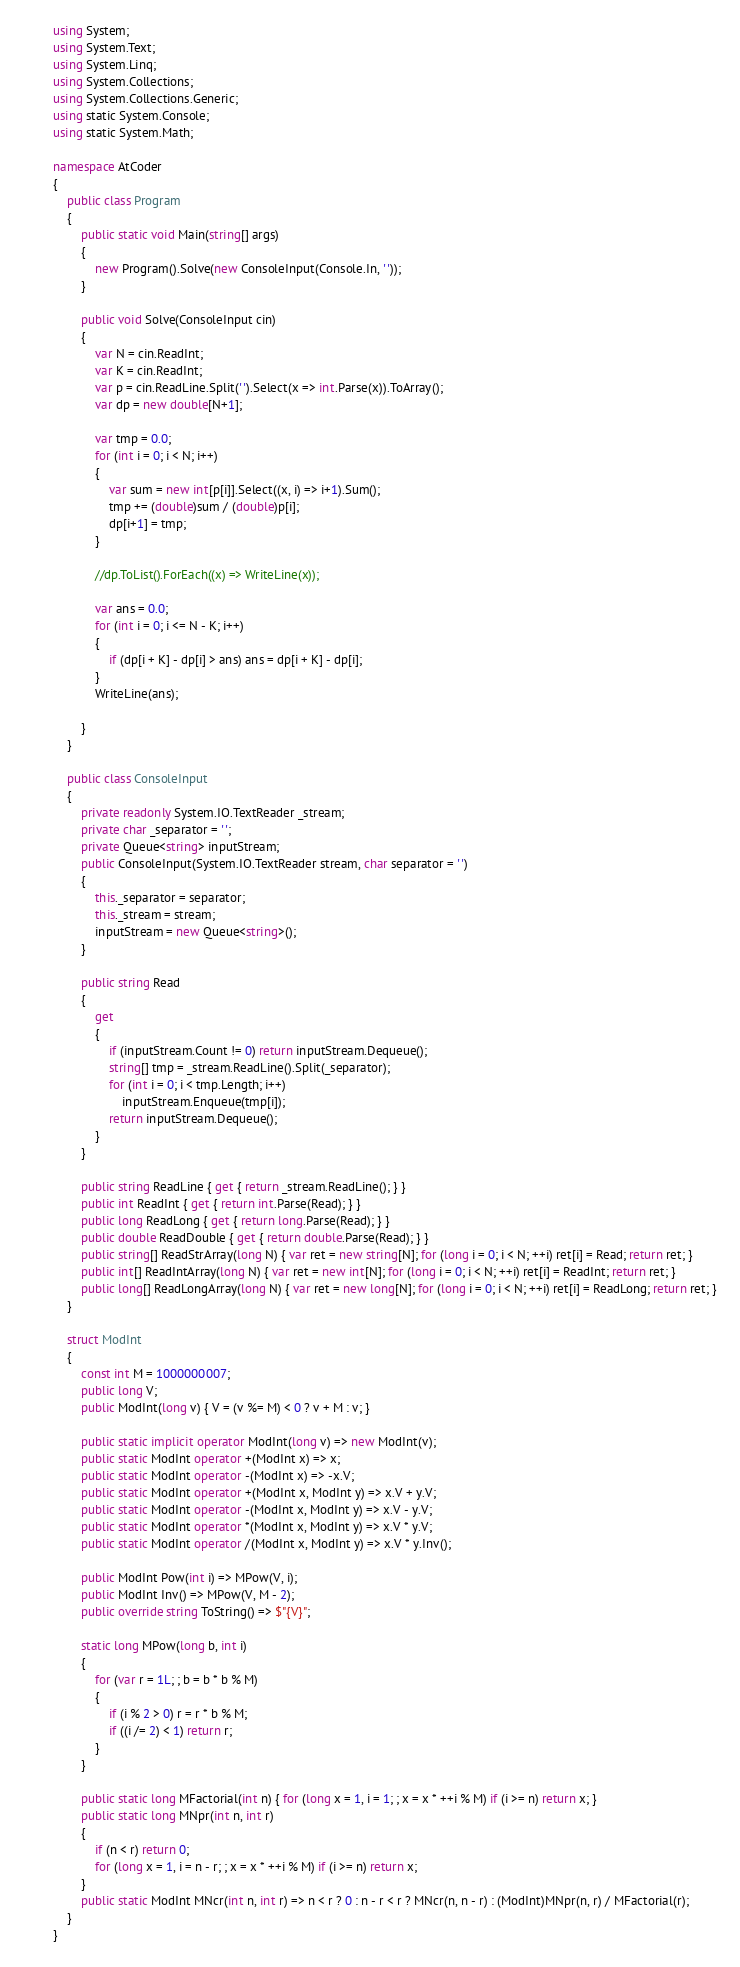Convert code to text. <code><loc_0><loc_0><loc_500><loc_500><_C#_>using System;
using System.Text;
using System.Linq;
using System.Collections;
using System.Collections.Generic;
using static System.Console;
using static System.Math;

namespace AtCoder
{
    public class Program
    {
        public static void Main(string[] args)
        {
            new Program().Solve(new ConsoleInput(Console.In, ' '));
        }

        public void Solve(ConsoleInput cin)
        {
            var N = cin.ReadInt;
            var K = cin.ReadInt;
            var p = cin.ReadLine.Split(' ').Select(x => int.Parse(x)).ToArray();
            var dp = new double[N+1];

            var tmp = 0.0;
            for (int i = 0; i < N; i++)
            {
                var sum = new int[p[i]].Select((x, i) => i+1).Sum();
                tmp += (double)sum / (double)p[i];
                dp[i+1] = tmp;
            }

            //dp.ToList().ForEach((x) => WriteLine(x));

            var ans = 0.0;
            for (int i = 0; i <= N - K; i++)
            {
                if (dp[i + K] - dp[i] > ans) ans = dp[i + K] - dp[i];
            }
            WriteLine(ans);

        }
    }

    public class ConsoleInput
    {
        private readonly System.IO.TextReader _stream;
        private char _separator = ' ';
        private Queue<string> inputStream;
        public ConsoleInput(System.IO.TextReader stream, char separator = ' ')
        {
            this._separator = separator;
            this._stream = stream;
            inputStream = new Queue<string>();
        }

        public string Read
        {
            get
            {
                if (inputStream.Count != 0) return inputStream.Dequeue();
                string[] tmp = _stream.ReadLine().Split(_separator);
                for (int i = 0; i < tmp.Length; i++)
                    inputStream.Enqueue(tmp[i]);
                return inputStream.Dequeue();
            }
        }

        public string ReadLine { get { return _stream.ReadLine(); } }
        public int ReadInt { get { return int.Parse(Read); } }
        public long ReadLong { get { return long.Parse(Read); } }
        public double ReadDouble { get { return double.Parse(Read); } }
        public string[] ReadStrArray(long N) { var ret = new string[N]; for (long i = 0; i < N; ++i) ret[i] = Read; return ret; }
        public int[] ReadIntArray(long N) { var ret = new int[N]; for (long i = 0; i < N; ++i) ret[i] = ReadInt; return ret; }
        public long[] ReadLongArray(long N) { var ret = new long[N]; for (long i = 0; i < N; ++i) ret[i] = ReadLong; return ret; }
    }

    struct ModInt
    {
        const int M = 1000000007;
        public long V;
        public ModInt(long v) { V = (v %= M) < 0 ? v + M : v; }

        public static implicit operator ModInt(long v) => new ModInt(v);
        public static ModInt operator +(ModInt x) => x;
        public static ModInt operator -(ModInt x) => -x.V;
        public static ModInt operator +(ModInt x, ModInt y) => x.V + y.V;
        public static ModInt operator -(ModInt x, ModInt y) => x.V - y.V;
        public static ModInt operator *(ModInt x, ModInt y) => x.V * y.V;
        public static ModInt operator /(ModInt x, ModInt y) => x.V * y.Inv();

        public ModInt Pow(int i) => MPow(V, i);
        public ModInt Inv() => MPow(V, M - 2);
        public override string ToString() => $"{V}";

        static long MPow(long b, int i)
        {
            for (var r = 1L; ; b = b * b % M)
            {
                if (i % 2 > 0) r = r * b % M;
                if ((i /= 2) < 1) return r;
            }
        }

        public static long MFactorial(int n) { for (long x = 1, i = 1; ; x = x * ++i % M) if (i >= n) return x; }
        public static long MNpr(int n, int r)
        {
            if (n < r) return 0;
            for (long x = 1, i = n - r; ; x = x * ++i % M) if (i >= n) return x;
        }
        public static ModInt MNcr(int n, int r) => n < r ? 0 : n - r < r ? MNcr(n, n - r) : (ModInt)MNpr(n, r) / MFactorial(r);
    }
}
</code> 